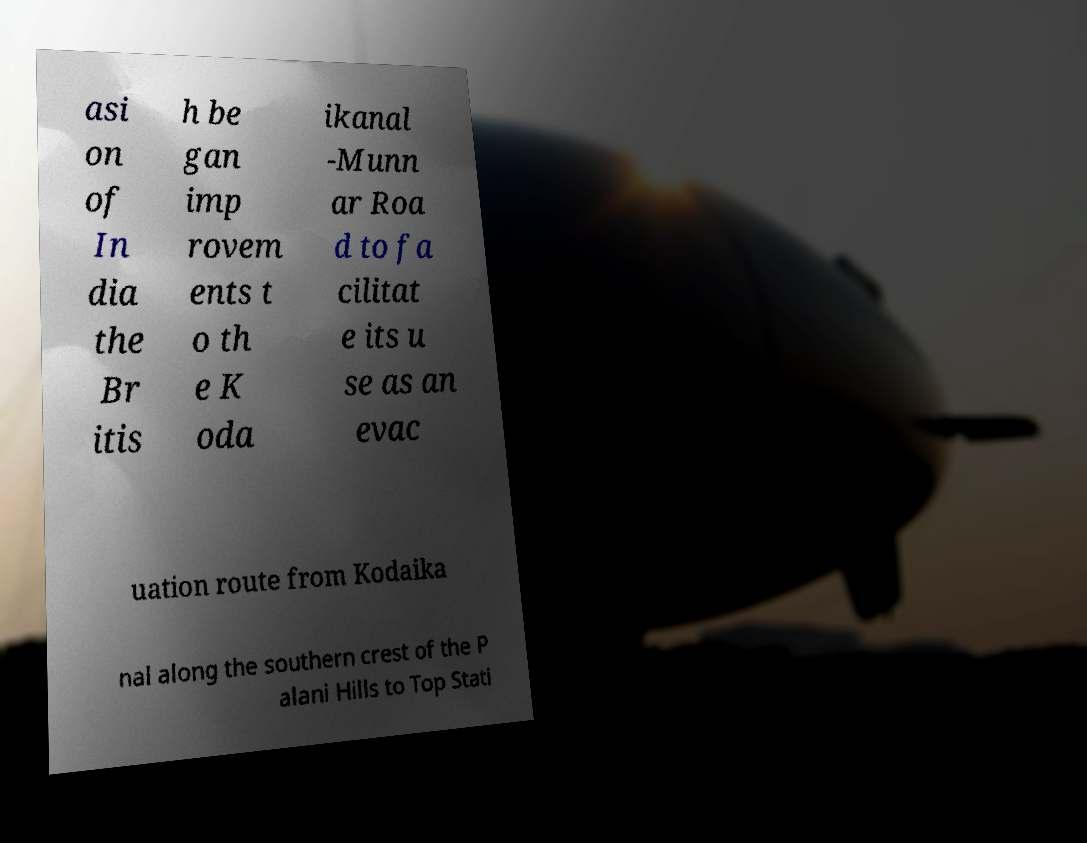There's text embedded in this image that I need extracted. Can you transcribe it verbatim? asi on of In dia the Br itis h be gan imp rovem ents t o th e K oda ikanal -Munn ar Roa d to fa cilitat e its u se as an evac uation route from Kodaika nal along the southern crest of the P alani Hills to Top Stati 